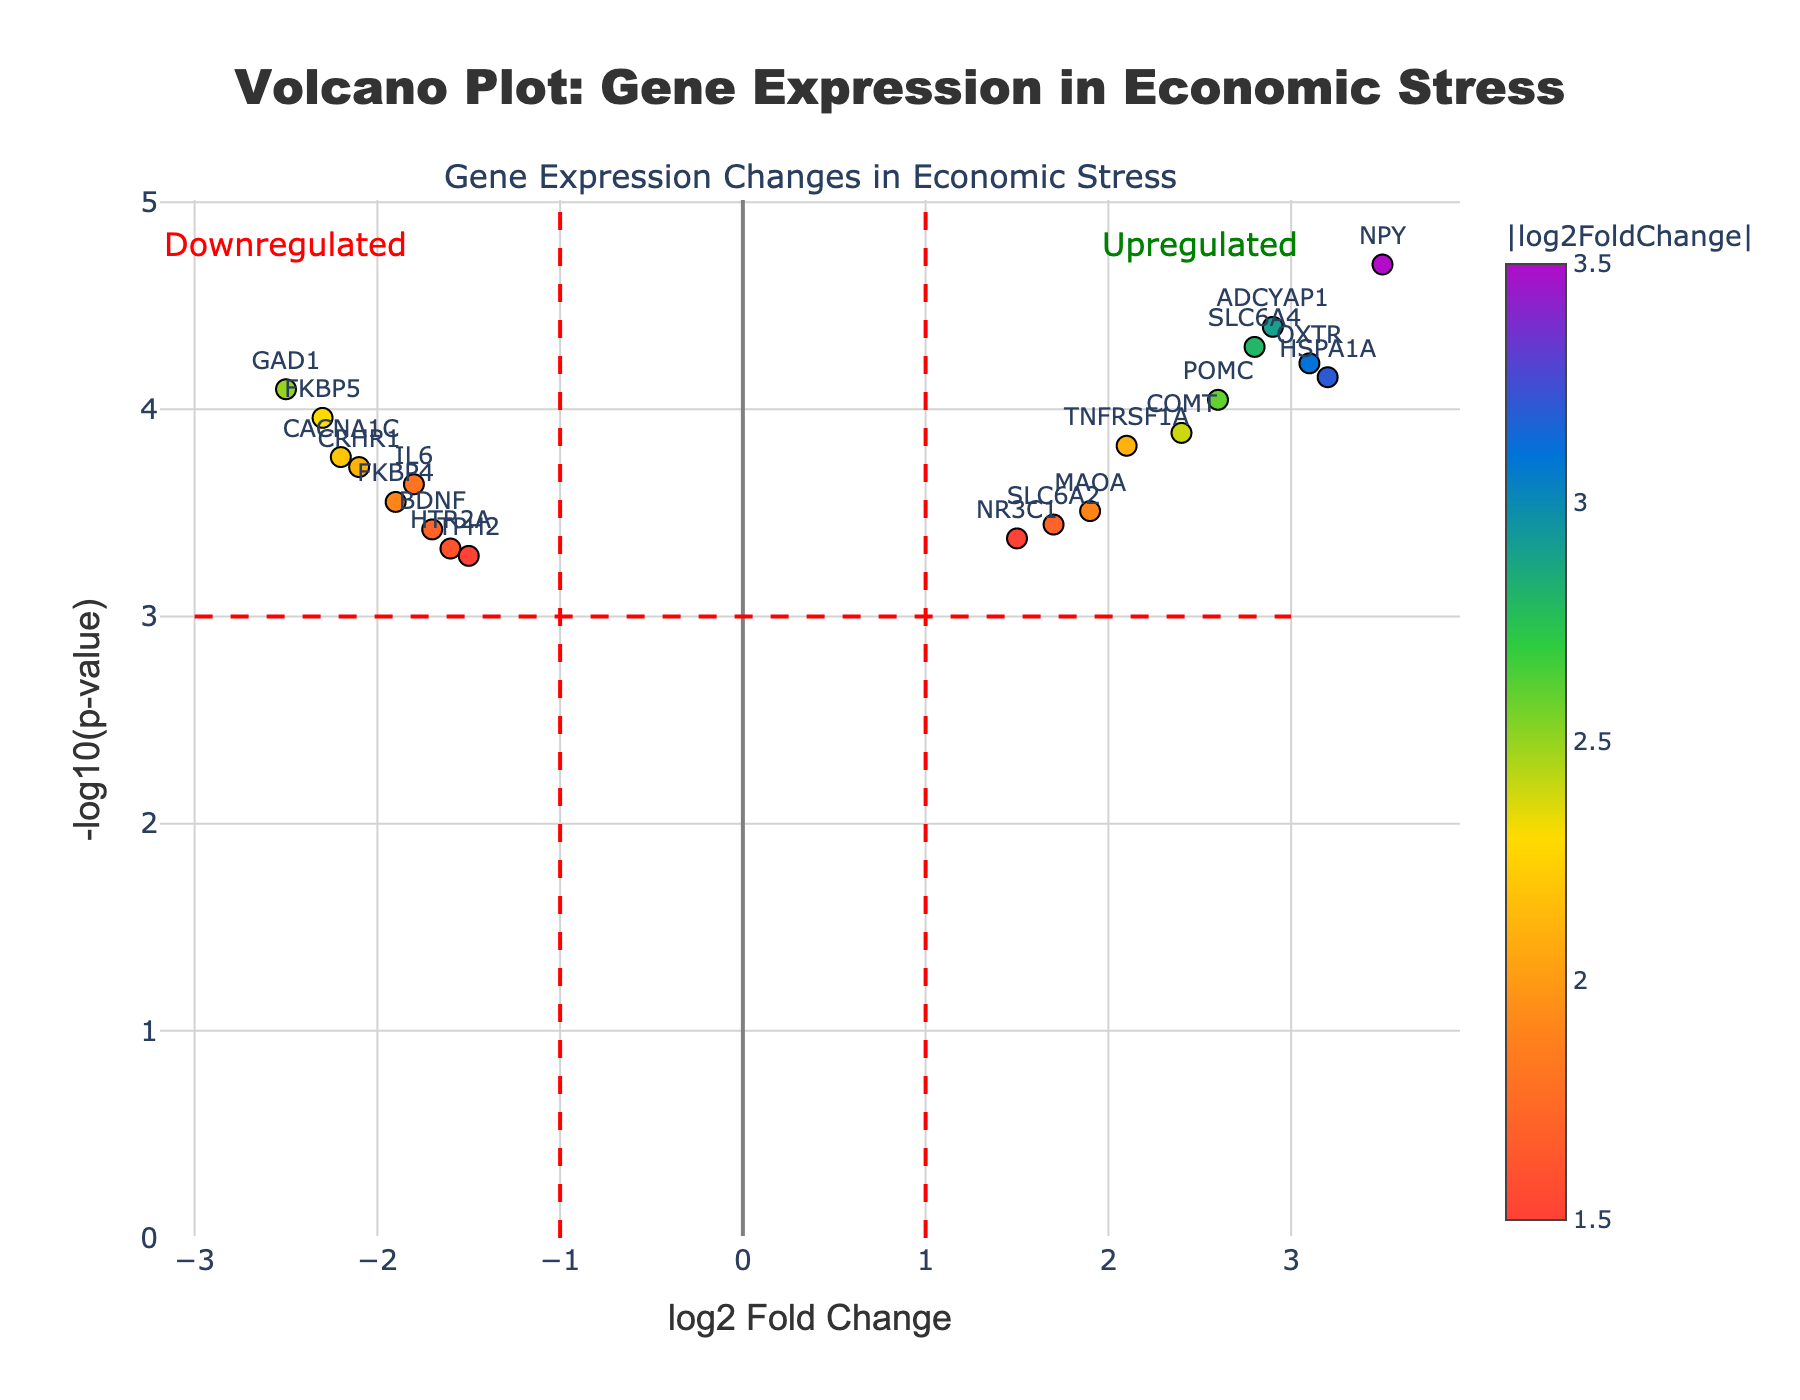What is the title of the plot? The title of the plot is usually positioned at the top center of the figure. It succinctly describes the information being presented. In this case, it's "Volcano Plot: Gene Expression in Economic Stress".
Answer: Volcano Plot: Gene Expression in Economic Stress How are upregulated and downregulated genes annotated? Upregulated genes typically have positive log2FoldChange values and are labeled "Upregulated". Similarly, downregulated genes have negative log2FoldChange values and are labeled "Downregulated". These annotations are visually represented near the top of the plot with text and colors.
Answer: Upregulated and Downregulated What is the log2FoldChange threshold beyond which genes are considered significantly upregulated or downregulated? The threshold lines are drawn at log2FoldChange of +1 and -1. Genes beyond these thresholds are considered significantly upregulated or downregulated. This can be inferred from annotation lines and text in the plot.
Answer: +1 and -1 Which data point has the highest -log10(p-value)? The -log10(p-value) is visually represented on the y-axis. The data point that reaches the highest value on this axis from the plot corresponds to the gene with the highest statistical significance. In this case, it's "NPY", with a value of 4.7.
Answer: NPY How many genes are significantly upregulated (log2FoldChange > 1 and p-value < 0.05)? By counting the points on the plot that fall in the right half (log2FoldChange > 1) and above the horizontal line representing p-value < 0.05, we find 7 genes meeting these criteria. These genes are labeled on the plot.
Answer: 7 genes Which genes are downregulated with a log2FoldChange less than -2? Downregulated genes with a log2FoldChange less than -2 can be identified by examining the left side of the plot beyond the -2 mark. The relevant genes here are FKBP5, GAD1, and CACNA1C, as shown by their relative positions in the plot.
Answer: FKBP5, GAD1, CACNA1C Which gene has the closest log2FoldChange to zero yet remains statistically significant? To find the gene with a log2FoldChange closest to zero, we look for points near the y-axis (log2FoldChange = 0) but still above the p-value significance threshold line. "HTR2A" has a log2FoldChange of -1.5, which is closest to zero among significant genes.
Answer: HTR2A What does the color gradient of the data points represent? The color gradient represents the absolute values of log2FoldChange. Data points with higher absolute values are marked with different colors according to the color scale provided, visually distinguishing more extreme changes in expression levels.
Answer: Absolute log2FoldChange values Which gene has the most extreme positive log2FoldChange? The gene farthest to the right on the x-axis represents the most positively upregulated gene. "NPY" has the highest positive log2FoldChange of 3.5.
Answer: NPY 